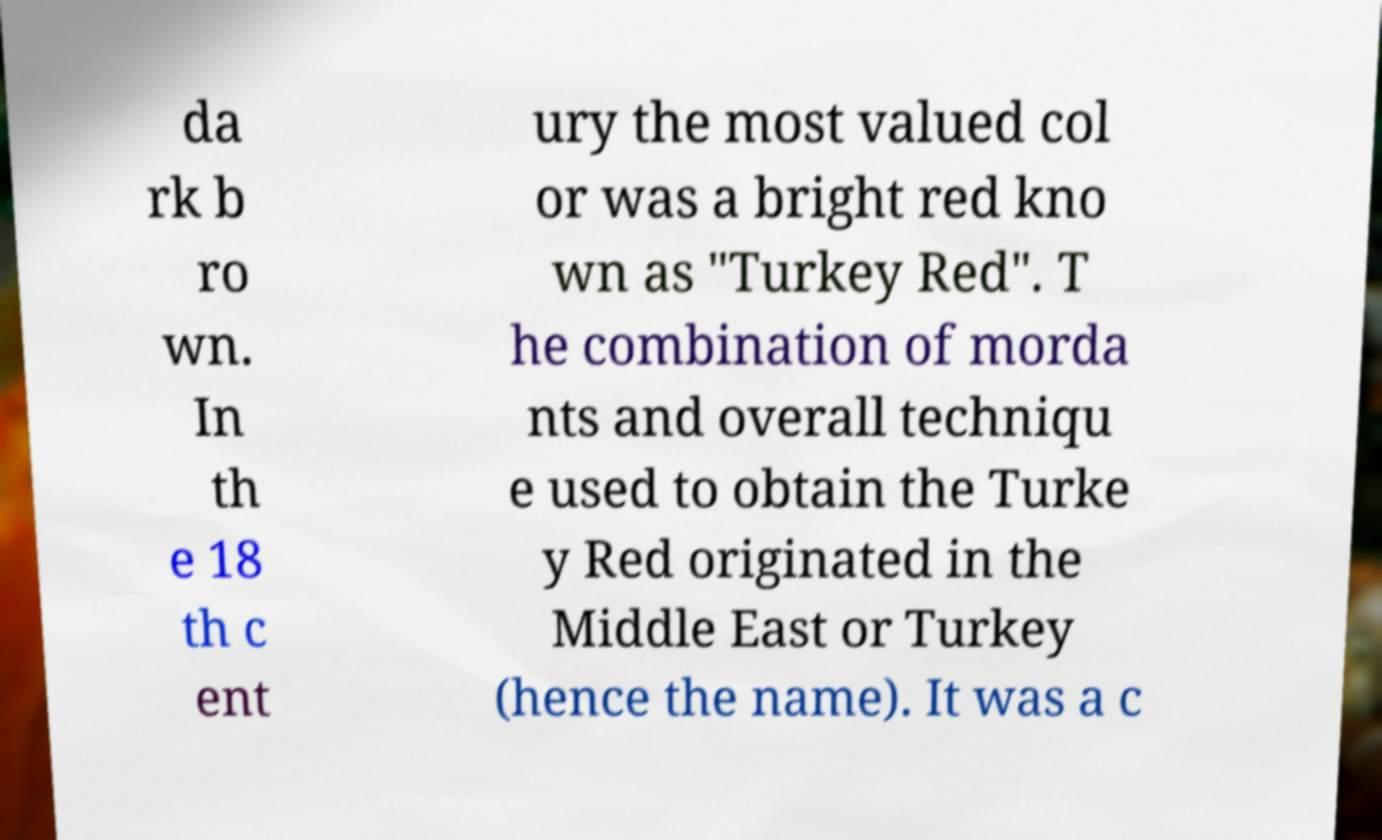Could you assist in decoding the text presented in this image and type it out clearly? da rk b ro wn. In th e 18 th c ent ury the most valued col or was a bright red kno wn as "Turkey Red". T he combination of morda nts and overall techniqu e used to obtain the Turke y Red originated in the Middle East or Turkey (hence the name). It was a c 